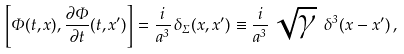Convert formula to latex. <formula><loc_0><loc_0><loc_500><loc_500>\left [ \Phi ( t , { x } ) , \frac { \partial \Phi } { \partial t } ( t , { x ^ { \prime } } ) \right ] = \frac { i } { a ^ { 3 } } \, \delta _ { \Sigma } ( { x } , { x ^ { \prime } } ) \equiv \frac { i } { a ^ { 3 } } \, \sqrt { \gamma } \ \delta ^ { 3 } ( { x } - { x ^ { \prime } } ) \, ,</formula> 